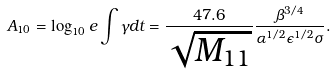Convert formula to latex. <formula><loc_0><loc_0><loc_500><loc_500>A _ { 1 0 } = \log _ { 1 0 } e \int \gamma d t = \frac { 4 7 . 6 } { \sqrt { M _ { 1 1 } } } \frac { \beta ^ { 3 / 4 } } { \alpha ^ { 1 / 2 } \epsilon ^ { 1 / 2 } \sigma } .</formula> 